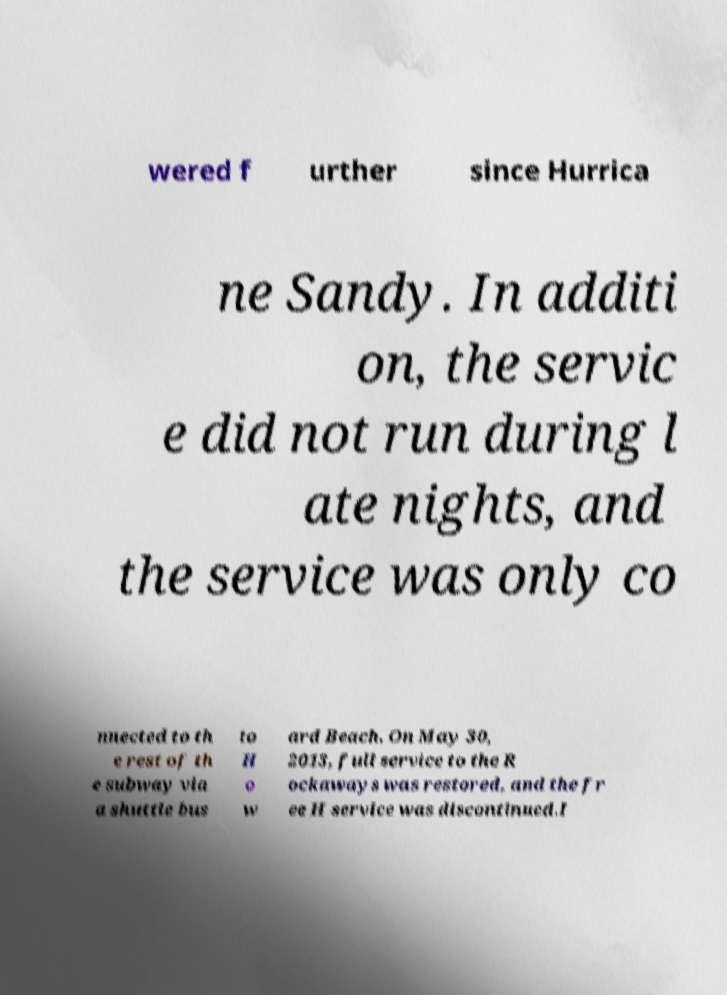Can you read and provide the text displayed in the image?This photo seems to have some interesting text. Can you extract and type it out for me? wered f urther since Hurrica ne Sandy. In additi on, the servic e did not run during l ate nights, and the service was only co nnected to th e rest of th e subway via a shuttle bus to H o w ard Beach. On May 30, 2013, full service to the R ockaways was restored, and the fr ee H service was discontinued.I 